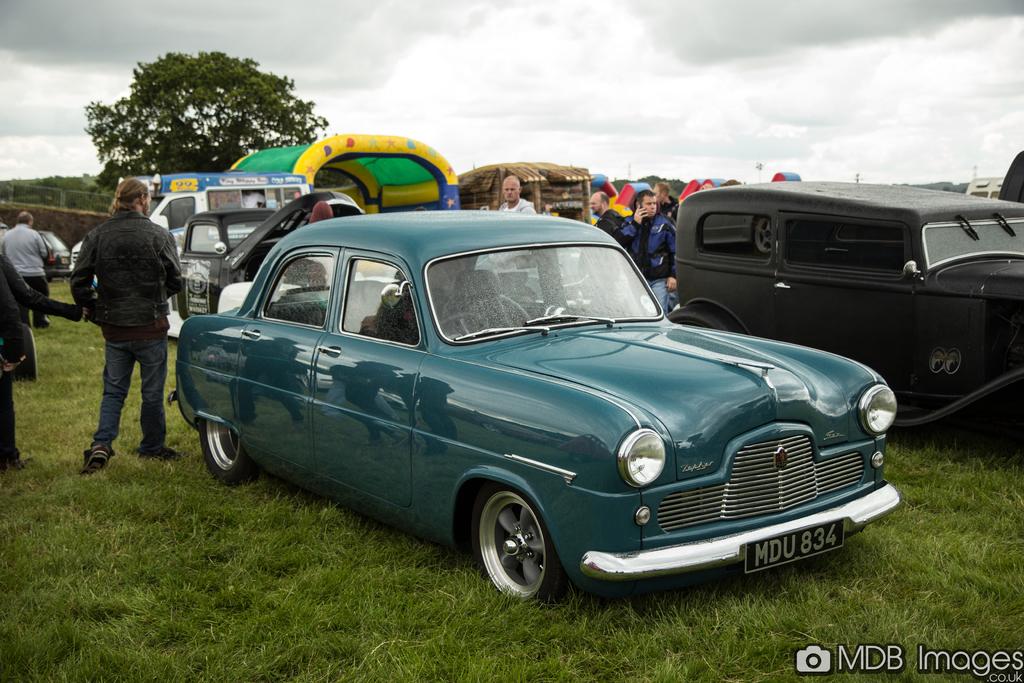What is the licence plate number on the blue classic car?
Your answer should be compact. Mdu 834. 